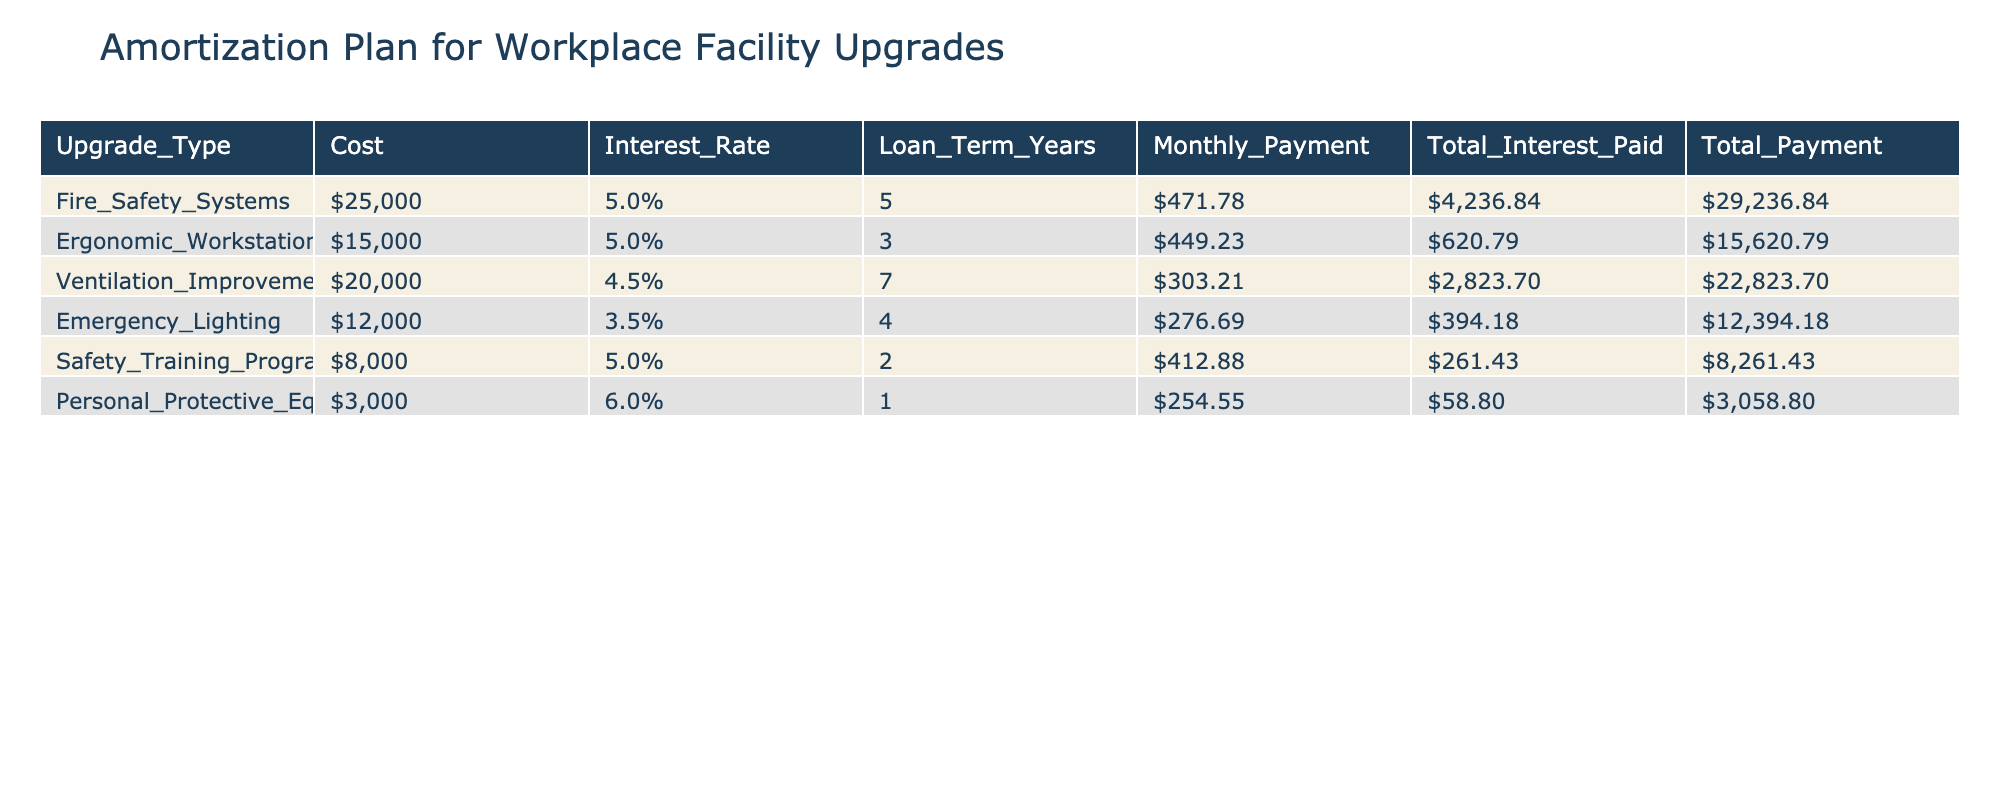What is the highest cost for an upgrade plan? The table lists the costs for each upgrade. Scanning through the costs, Fire Safety Systems costs $25,000, which is higher than any other listed costs.
Answer: $25,000 What is the monthly payment for the Emergency Lighting upgrade? The Monthly Payment column specifies $276.69 for Emergency Lighting, which is directly visible in that row.
Answer: $276.69 Is the Total Interest Paid for Personal Protective Equipment greater than $50? The Total Interest Paid for Personal Protective Equipment is listed as $58.80, which is indeed greater than $50.
Answer: Yes What is the Total Payment for Ergonomic Workstations? For Ergonomic Workstations, the Total Payment is $15,620.79, visible in the respective row under the Total Payment column.
Answer: $15,620.79 Which upgrade has the lowest interest rate and what is that rate? By reviewing the Interest Rate column, the lowest rate is 3.5% for Emergency Lighting. Comparing other rates confirms this as the lowest.
Answer: 3.5% What is the difference in total payments between the Ventilation Improvements and Safety Training Programs? The Total Payment for Ventilation Improvements is $22,823.70, and for Safety Training Programs, it is $8,261.43. The difference calculated is $22,823.70 - $8,261.43 = $14,562.27.
Answer: $14,562.27 Can you determine the average monthly payment of all the upgrades listed? The Monthly Payments for all upgrades are $471.78, $449.23, $303.21, $276.69, $412.88, and $254.55. Adding these gives $2,168.34 and dividing by the number of upgrades (6) gives an average of $361.39.
Answer: $361.39 Is the total cost of Fire Safety Systems greater than all other upgrade costs combined? The combined costs of the other upgrades (Ergonomic Workstations, Ventilation Improvements, Emergency Lighting, Safety Training Programs, and Personal Protective Equipment) sum to $56,000. Since $25,000 is less than $56,000, the statement is false.
Answer: No What is the total interest paid for all upgrades combined? Summing the Total Interest Paid from the table: $4,236.84 (Fire Safety) + $620.79 (Ergonomic) + $2,823.70 (Ventilation) + $394.18 (Emergency Lighting) + $261.43 (Training) + $58.80 (PPE) yields $8,395.74.
Answer: $8,395.74 